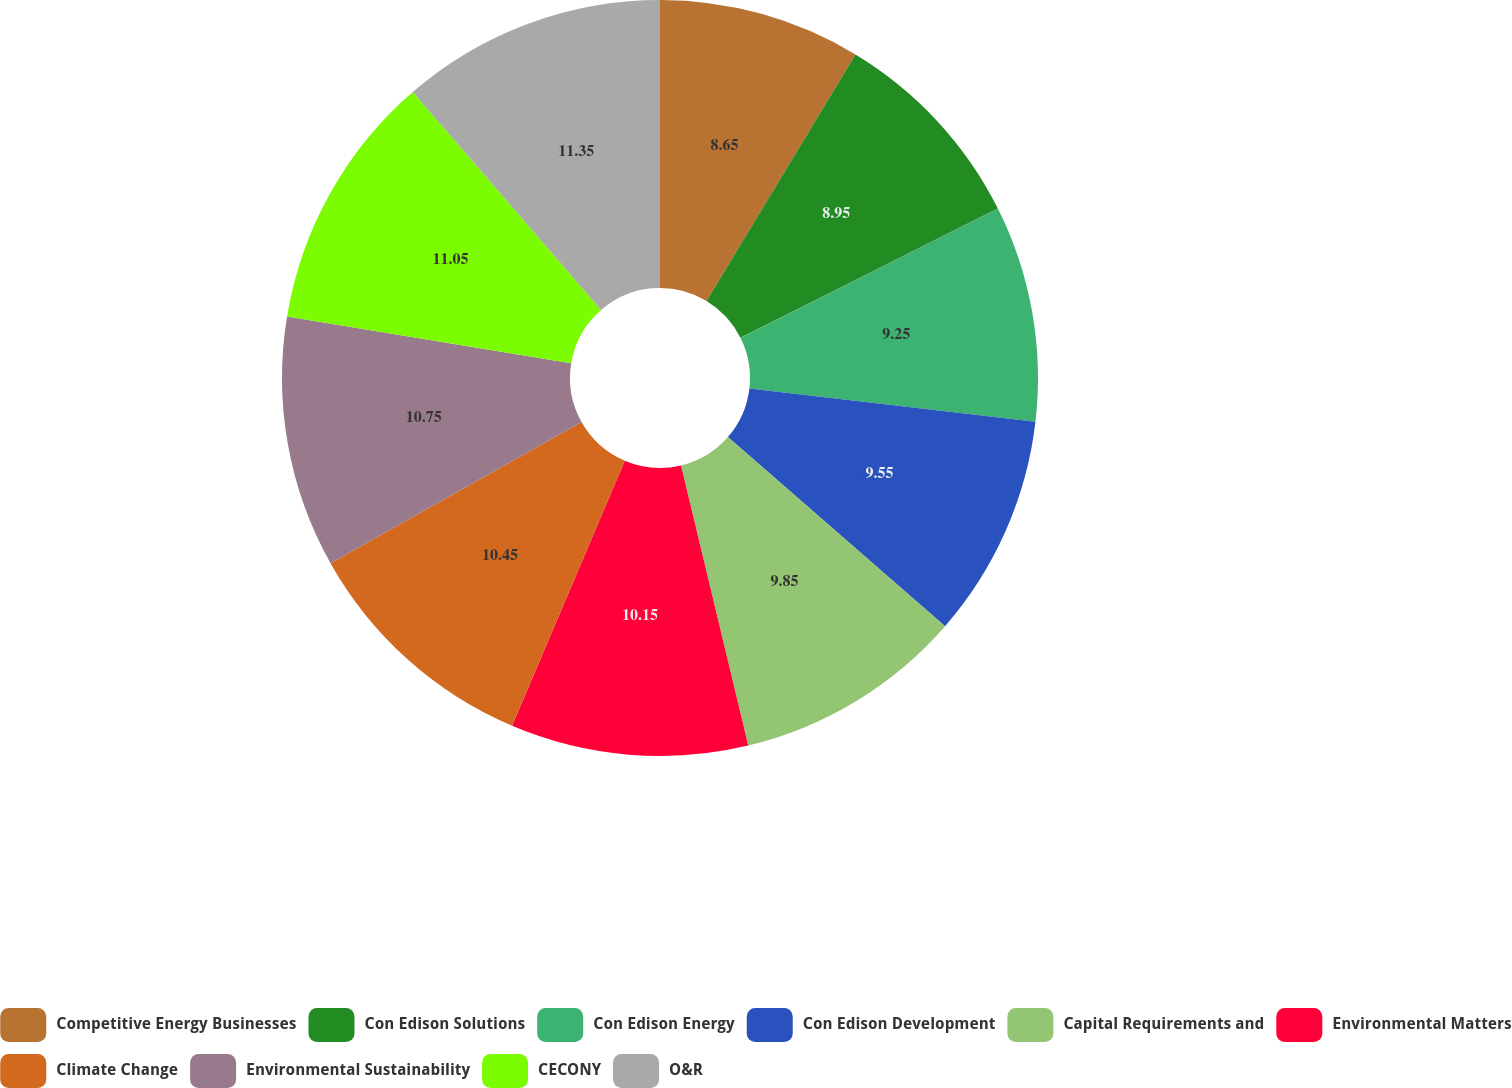Convert chart to OTSL. <chart><loc_0><loc_0><loc_500><loc_500><pie_chart><fcel>Competitive Energy Businesses<fcel>Con Edison Solutions<fcel>Con Edison Energy<fcel>Con Edison Development<fcel>Capital Requirements and<fcel>Environmental Matters<fcel>Climate Change<fcel>Environmental Sustainability<fcel>CECONY<fcel>O&R<nl><fcel>8.65%<fcel>8.95%<fcel>9.25%<fcel>9.55%<fcel>9.85%<fcel>10.15%<fcel>10.45%<fcel>10.75%<fcel>11.05%<fcel>11.35%<nl></chart> 